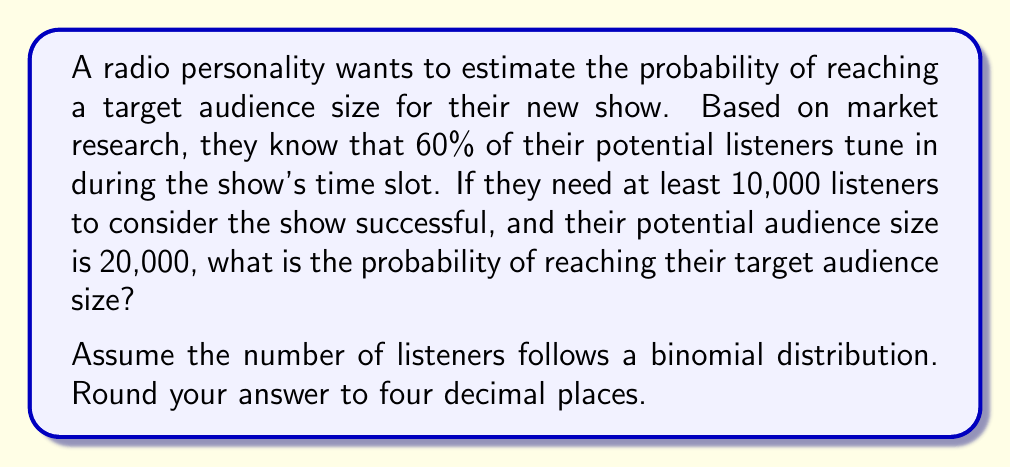Show me your answer to this math problem. Let's approach this step-by-step:

1) We have a binomial distribution with the following parameters:
   $n = 20,000$ (total potential audience)
   $p = 0.60$ (probability of an individual tuning in)
   $x \geq 10,000$ (we want at least 10,000 listeners)

2) The probability of success is the probability of getting 10,000 or more listeners. We can calculate this as:

   $P(X \geq 10,000) = 1 - P(X < 10,000) = 1 - P(X \leq 9,999)$

3) For large $n$ and $np > 5$, we can approximate the binomial distribution with a normal distribution:

   $X \sim N(np, np(1-p))$

4) In this case:
   $\mu = np = 20,000 * 0.60 = 12,000$
   $\sigma^2 = np(1-p) = 20,000 * 0.60 * 0.40 = 4,800$
   $\sigma = \sqrt{4,800} = 69.28$

5) We need to find:
   $P(X \geq 10,000) = 1 - P(X < 10,000)$

6) Standardizing:
   $z = \frac{9999.5 - 12,000}{69.28} = -28.87$

7) Using the standard normal distribution table or calculator:
   $P(Z < -28.87) \approx 0$

8) Therefore:
   $P(X \geq 10,000) = 1 - P(X < 10,000) = 1 - 0 = 1$

9) Rounding to four decimal places: 1.0000
Answer: 1.0000 